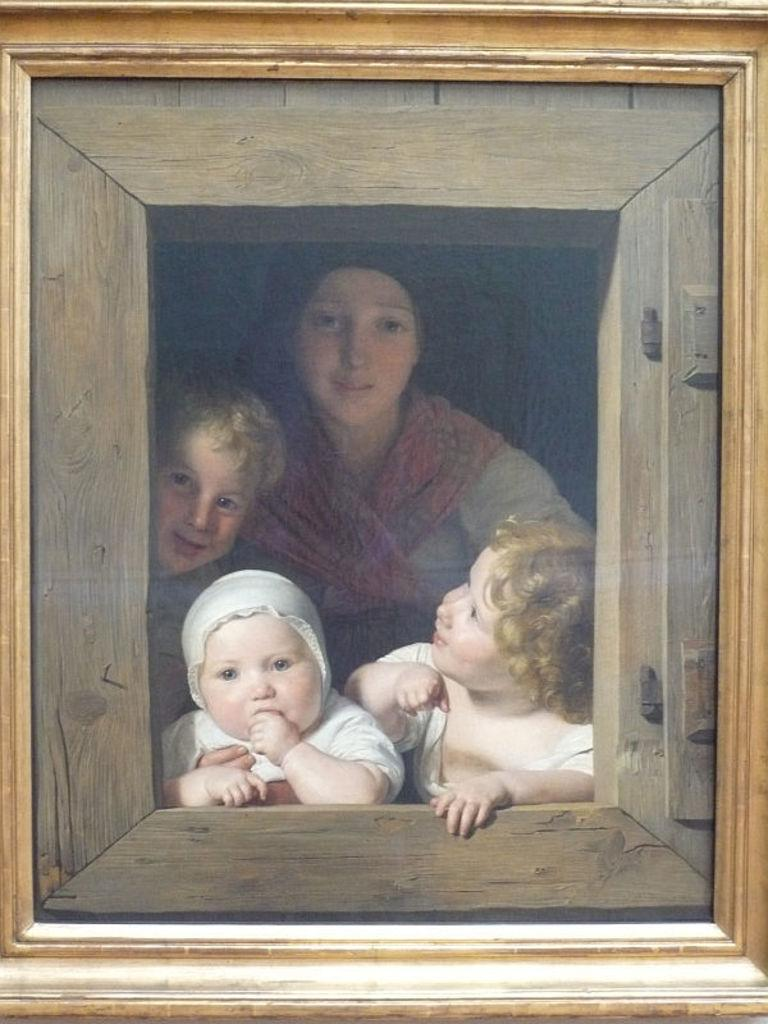What is the main subject of the image? There is a painting in the image. What is depicted in the painting? The painting depicts a person and three kids. What is the color and material of the painting's frame? The frame of the painting is gold and wooden in color. How many sacks can be seen in the painting? There are no sacks depicted in the painting; it features a person and three kids. What type of kitty can be seen playing with the pigs in the painting? There are no pigs or kitties present in the painting; it depicts a person and three kids. 